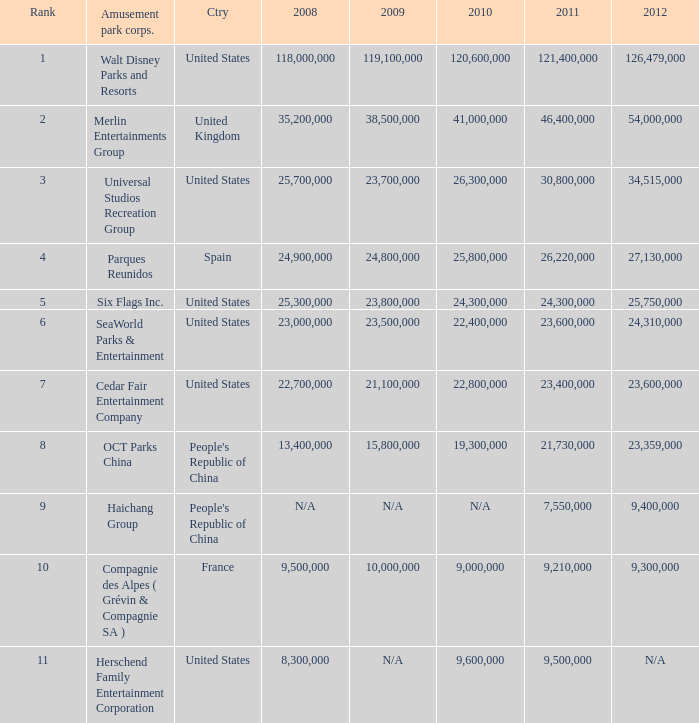In the United States the 2011 attendance at this amusement park corporation was larger than 30,800,000 but lists what as its 2008 attendance? 118000000.0. 